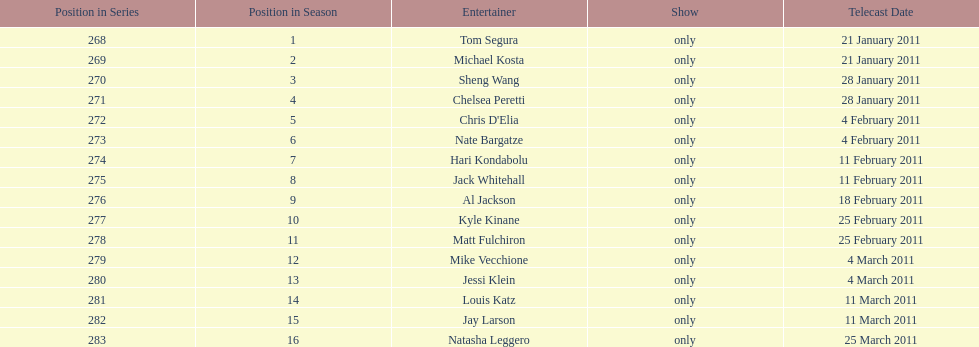How many episodes only had one performer? 16. Would you mind parsing the complete table? {'header': ['Position in Series', 'Position in Season', 'Entertainer', 'Show', 'Telecast Date'], 'rows': [['268', '1', 'Tom Segura', 'only', '21 January 2011'], ['269', '2', 'Michael Kosta', 'only', '21 January 2011'], ['270', '3', 'Sheng Wang', 'only', '28 January 2011'], ['271', '4', 'Chelsea Peretti', 'only', '28 January 2011'], ['272', '5', "Chris D'Elia", 'only', '4 February 2011'], ['273', '6', 'Nate Bargatze', 'only', '4 February 2011'], ['274', '7', 'Hari Kondabolu', 'only', '11 February 2011'], ['275', '8', 'Jack Whitehall', 'only', '11 February 2011'], ['276', '9', 'Al Jackson', 'only', '18 February 2011'], ['277', '10', 'Kyle Kinane', 'only', '25 February 2011'], ['278', '11', 'Matt Fulchiron', 'only', '25 February 2011'], ['279', '12', 'Mike Vecchione', 'only', '4 March 2011'], ['280', '13', 'Jessi Klein', 'only', '4 March 2011'], ['281', '14', 'Louis Katz', 'only', '11 March 2011'], ['282', '15', 'Jay Larson', 'only', '11 March 2011'], ['283', '16', 'Natasha Leggero', 'only', '25 March 2011']]} 